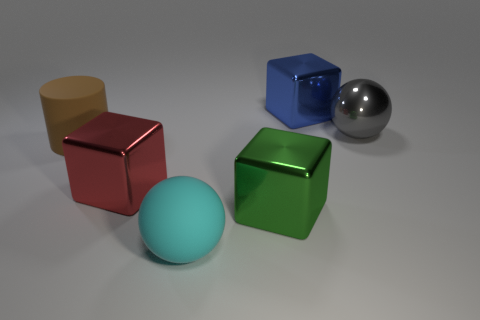What number of things are small blue rubber blocks or brown rubber objects?
Keep it short and to the point. 1. Is the large rubber ball the same color as the large metal sphere?
Ensure brevity in your answer.  No. Are there any other things that are the same size as the brown object?
Your answer should be very brief. Yes. There is a large matte thing that is left of the large cyan rubber thing that is in front of the blue object; what is its shape?
Your response must be concise. Cylinder. Is the number of big blue metal cubes less than the number of tiny cyan things?
Offer a very short reply. No. There is a block that is both behind the big green metal thing and in front of the large gray sphere; what size is it?
Offer a terse response. Large. Do the brown cylinder and the green metallic block have the same size?
Your answer should be compact. Yes. Is the color of the large rubber thing that is behind the big cyan rubber ball the same as the large metallic ball?
Give a very brief answer. No. There is a gray metal thing; what number of gray objects are right of it?
Offer a terse response. 0. Is the number of yellow rubber cylinders greater than the number of big brown objects?
Your response must be concise. No. 